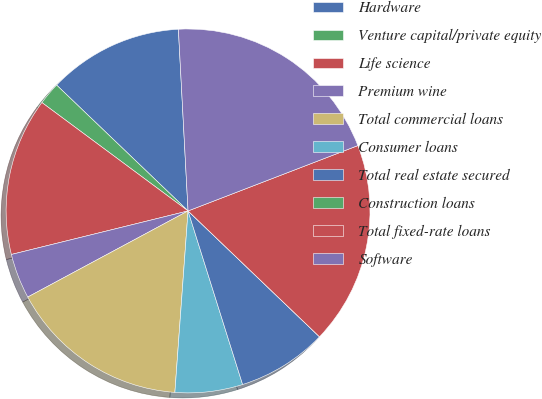<chart> <loc_0><loc_0><loc_500><loc_500><pie_chart><fcel>Hardware<fcel>Venture capital/private equity<fcel>Life science<fcel>Premium wine<fcel>Total commercial loans<fcel>Consumer loans<fcel>Total real estate secured<fcel>Construction loans<fcel>Total fixed-rate loans<fcel>Software<nl><fcel>12.0%<fcel>2.0%<fcel>14.0%<fcel>4.0%<fcel>16.0%<fcel>6.0%<fcel>8.0%<fcel>0.0%<fcel>18.0%<fcel>20.0%<nl></chart> 